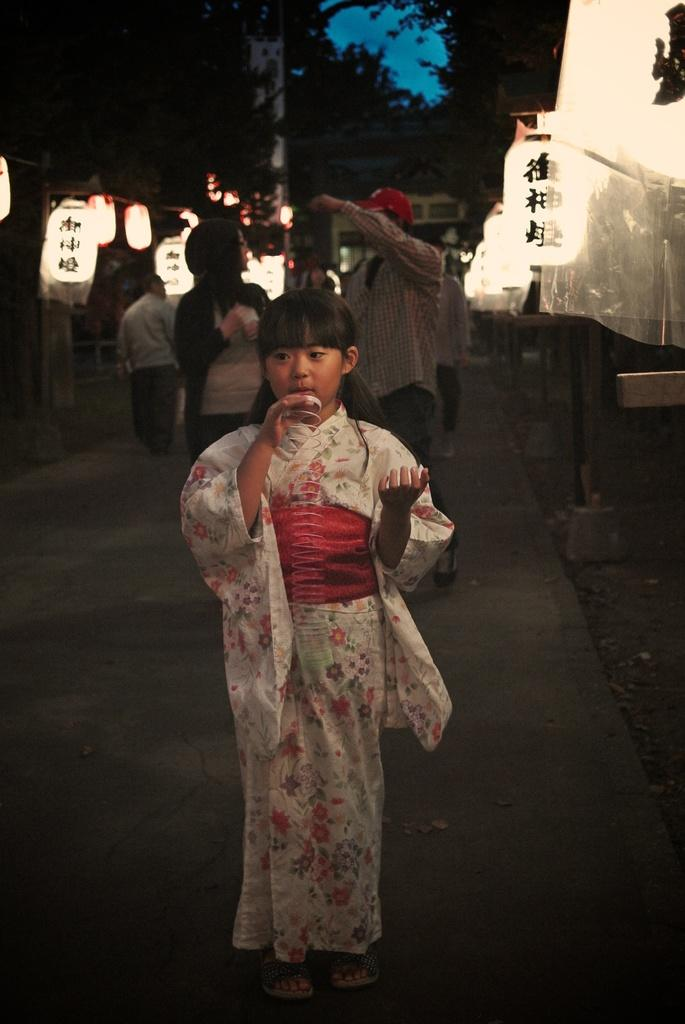What are the people in the image doing? The people in the image are standing on the road. What is the child holding in their hands? The child is holding a spring in their hands. What can be seen in the background of the image? Sky lanterns attached to poles and trees are visible in the background. What part of the natural environment is visible in the image? The sky is visible in the background. Can you tell me how many tests are being conducted in the image? There is no mention of any tests being conducted in the image. Is there a kitty visible in the image? There is no kitty present in the image. 